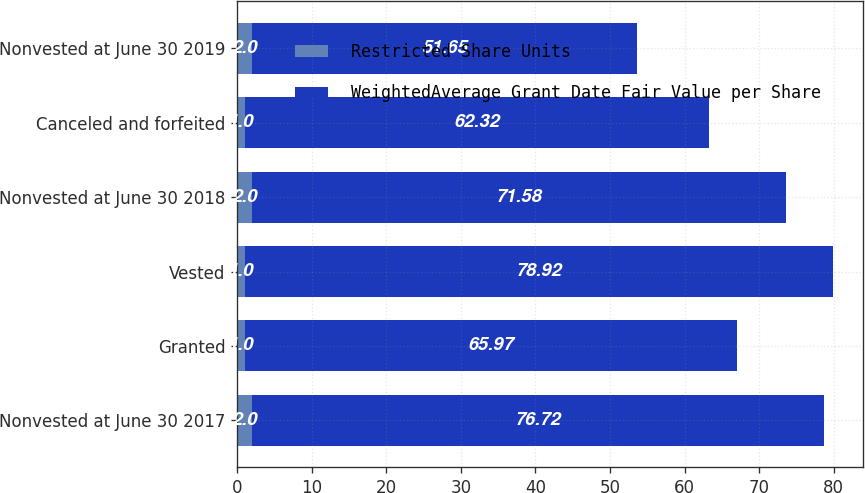<chart> <loc_0><loc_0><loc_500><loc_500><stacked_bar_chart><ecel><fcel>Nonvested at June 30 2017<fcel>Granted<fcel>Vested<fcel>Nonvested at June 30 2018<fcel>Canceled and forfeited<fcel>Nonvested at June 30 2019<nl><fcel>Restricted Share Units<fcel>2<fcel>1<fcel>1<fcel>2<fcel>1<fcel>2<nl><fcel>WeightedAverage Grant Date Fair Value per Share<fcel>76.72<fcel>65.97<fcel>78.92<fcel>71.58<fcel>62.32<fcel>51.65<nl></chart> 